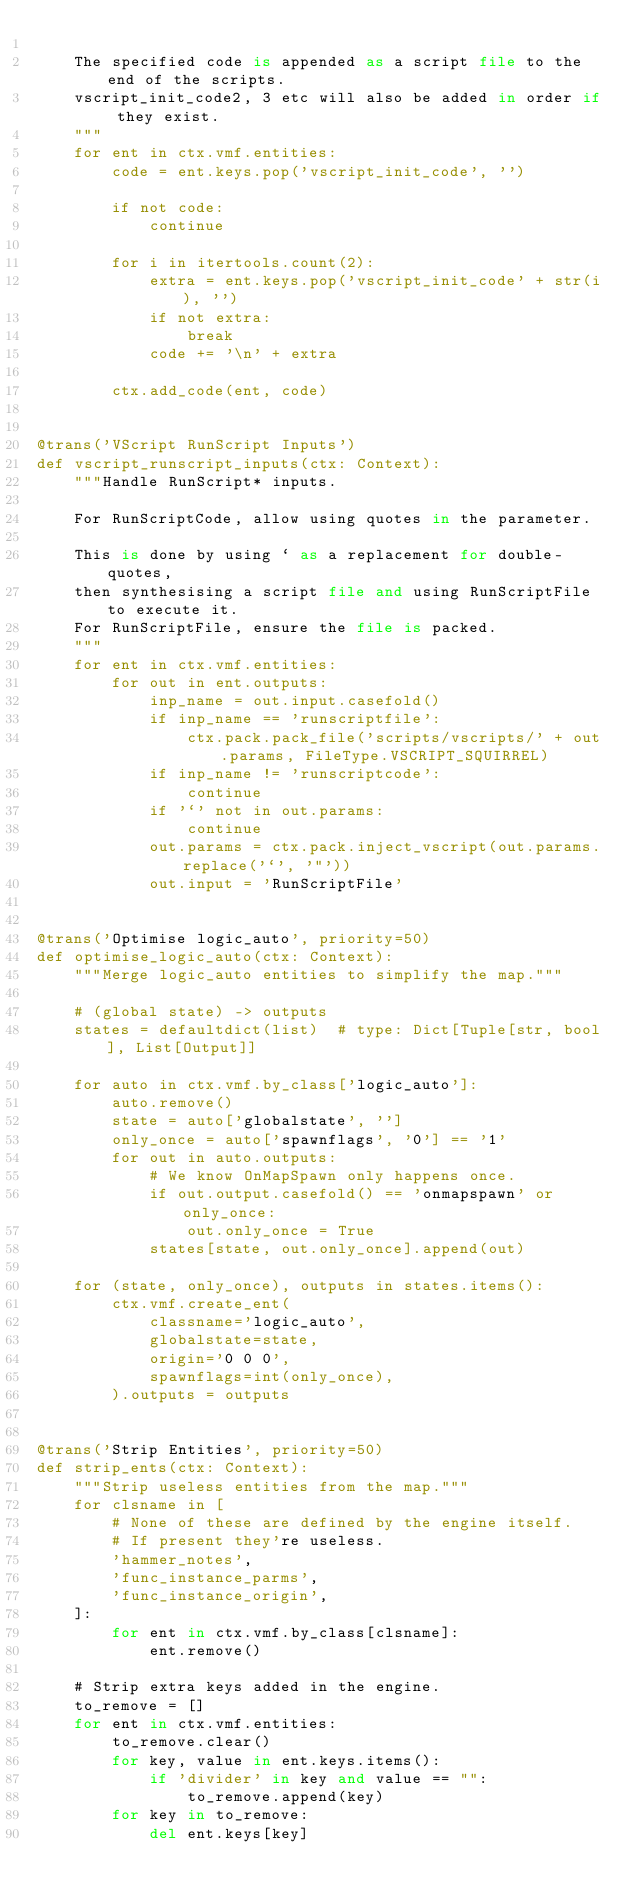<code> <loc_0><loc_0><loc_500><loc_500><_Python_>
    The specified code is appended as a script file to the end of the scripts.
    vscript_init_code2, 3 etc will also be added in order if they exist.
    """
    for ent in ctx.vmf.entities:
        code = ent.keys.pop('vscript_init_code', '')

        if not code:
            continue

        for i in itertools.count(2):
            extra = ent.keys.pop('vscript_init_code' + str(i), '')
            if not extra:
                break
            code += '\n' + extra

        ctx.add_code(ent, code)


@trans('VScript RunScript Inputs')
def vscript_runscript_inputs(ctx: Context):
    """Handle RunScript* inputs.

    For RunScriptCode, allow using quotes in the parameter.

    This is done by using ` as a replacement for double-quotes,
    then synthesising a script file and using RunScriptFile to execute it.
    For RunScriptFile, ensure the file is packed.
    """
    for ent in ctx.vmf.entities:
        for out in ent.outputs:
            inp_name = out.input.casefold()
            if inp_name == 'runscriptfile':
                ctx.pack.pack_file('scripts/vscripts/' + out.params, FileType.VSCRIPT_SQUIRREL)
            if inp_name != 'runscriptcode':
                continue
            if '`' not in out.params:
                continue
            out.params = ctx.pack.inject_vscript(out.params.replace('`', '"'))
            out.input = 'RunScriptFile'


@trans('Optimise logic_auto', priority=50)
def optimise_logic_auto(ctx: Context):
    """Merge logic_auto entities to simplify the map."""

    # (global state) -> outputs
    states = defaultdict(list)  # type: Dict[Tuple[str, bool], List[Output]]

    for auto in ctx.vmf.by_class['logic_auto']:
        auto.remove()
        state = auto['globalstate', '']
        only_once = auto['spawnflags', '0'] == '1'
        for out in auto.outputs:
            # We know OnMapSpawn only happens once.
            if out.output.casefold() == 'onmapspawn' or only_once:
                out.only_once = True
            states[state, out.only_once].append(out)

    for (state, only_once), outputs in states.items():
        ctx.vmf.create_ent(
            classname='logic_auto',
            globalstate=state,
            origin='0 0 0',
            spawnflags=int(only_once),
        ).outputs = outputs


@trans('Strip Entities', priority=50)
def strip_ents(ctx: Context):
    """Strip useless entities from the map."""
    for clsname in [
        # None of these are defined by the engine itself.
        # If present they're useless.
        'hammer_notes',
        'func_instance_parms',
        'func_instance_origin',
    ]:
        for ent in ctx.vmf.by_class[clsname]:
            ent.remove()

    # Strip extra keys added in the engine.
    to_remove = []
    for ent in ctx.vmf.entities:
        to_remove.clear()
        for key, value in ent.keys.items():
            if 'divider' in key and value == "":
                to_remove.append(key)
        for key in to_remove:
            del ent.keys[key]
</code> 